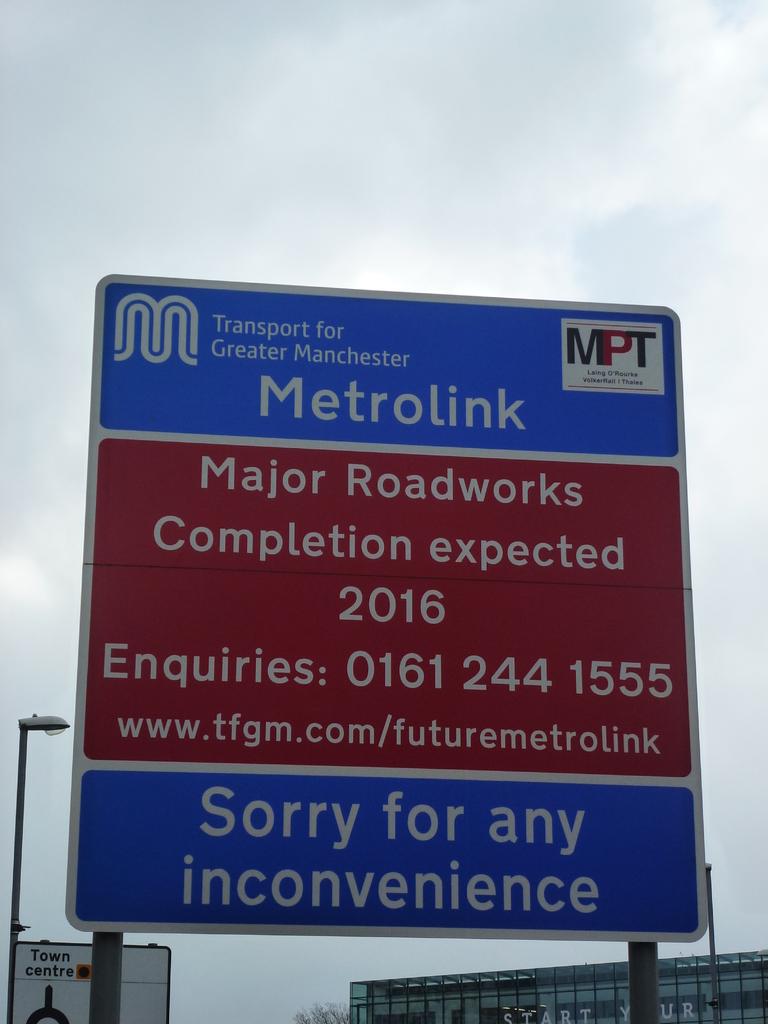When is the major roadwork completion expected to be?
Your response must be concise. 2016. What area is the sign in?
Your answer should be very brief. Greater manchester. 